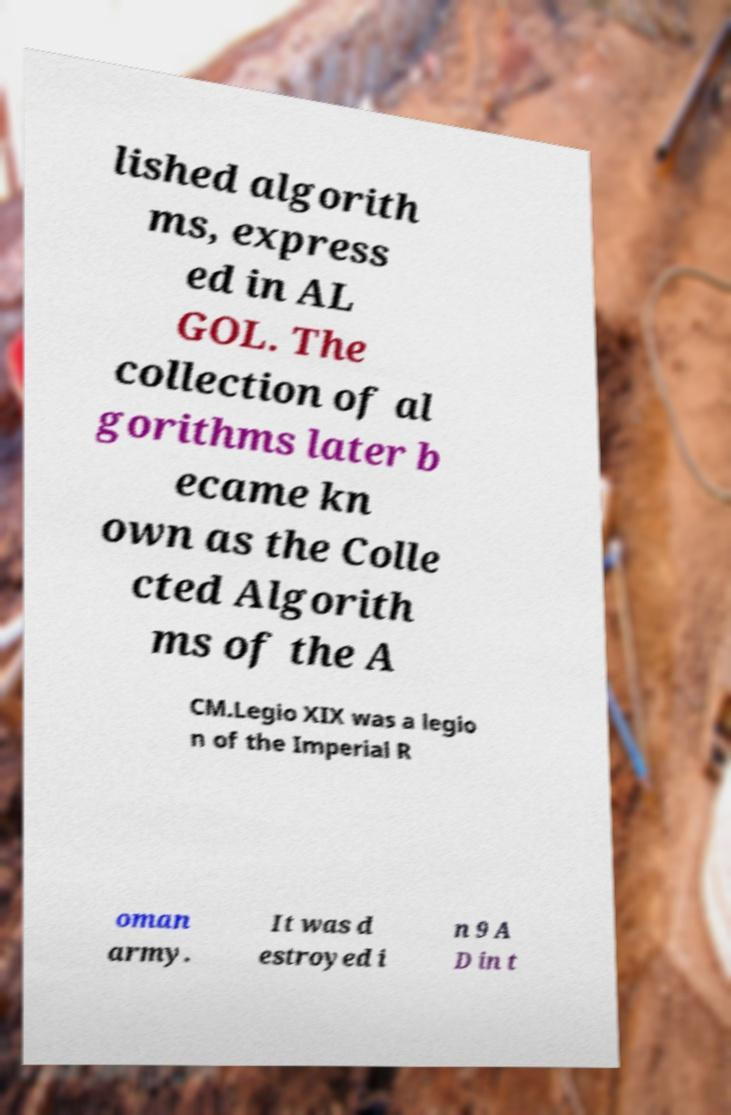For documentation purposes, I need the text within this image transcribed. Could you provide that? lished algorith ms, express ed in AL GOL. The collection of al gorithms later b ecame kn own as the Colle cted Algorith ms of the A CM.Legio XIX was a legio n of the Imperial R oman army. It was d estroyed i n 9 A D in t 